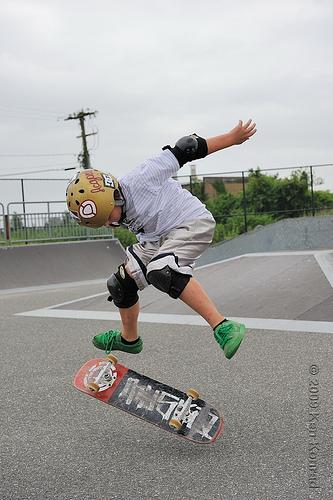What kind of infrastructure is present surrounding the boy? There is a chain link fence, a telephone post, and a skateboarding ramp in the area surrounding the boy. Count the number of wheels on the bottom of the skateboard. There are four wheels on the bottom of the skateboard. How would you assess the overall quality and composition of the image in terms of capturing the essence of the subject matter? The image effectively captures the thrilling essence of skateboarding with a well-composed focus on the boy, his skateboard, and the park setting which reflects the complexity and excitement of the sport. What kind of safety gear can you identify on the boy? The boy is wearing a helmet, knee pads, and elbow pads to ensure safety while skateboarding. Evaluate the emotional tone of this image based on the settings and activities. The image evokes a sense of excitement, dynamism, and youthful energy with a kid performing tricks on a skateboard in a skatepark. What is the main activity performed by the person in this image? The boy is skateboarding in the skatepark and performing a trick up in the air. Please provide a detailed description of the skateboard. The skateboard is upside down, displaying its bottom which has four wheels and it is flipped up during a trick. Provide a brief summary of the environment in which the scene takes place. The scene happens in a skatepark with gray sky, grey ground, a ramp, a chain link fence, and a telephone post in the background. Analyze the image and describe the type of footwear the skater has. The skater wears green sneakers that possibly provide good grip for skateboarding. Explain how the boy's outfit and accessories appear in the picture. The boy is wearing striped shirt, shorts, green sneakers, knee pads, a helmet, and elbow pads, all geared up for skateboarding. 